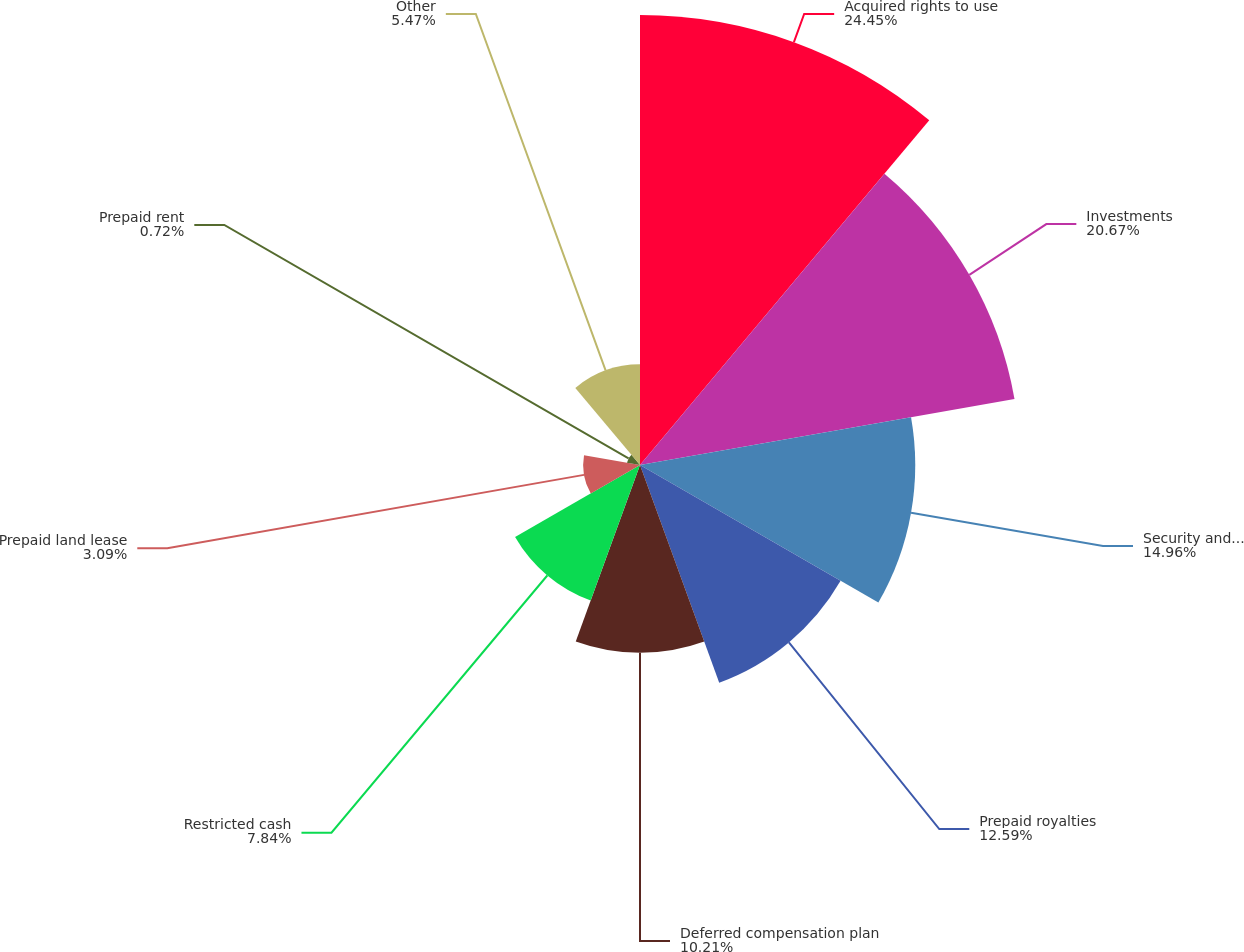Convert chart to OTSL. <chart><loc_0><loc_0><loc_500><loc_500><pie_chart><fcel>Acquired rights to use<fcel>Investments<fcel>Security and other deposits<fcel>Prepaid royalties<fcel>Deferred compensation plan<fcel>Restricted cash<fcel>Prepaid land lease<fcel>Prepaid rent<fcel>Other<nl><fcel>24.46%<fcel>20.67%<fcel>14.96%<fcel>12.59%<fcel>10.21%<fcel>7.84%<fcel>3.09%<fcel>0.72%<fcel>5.47%<nl></chart> 